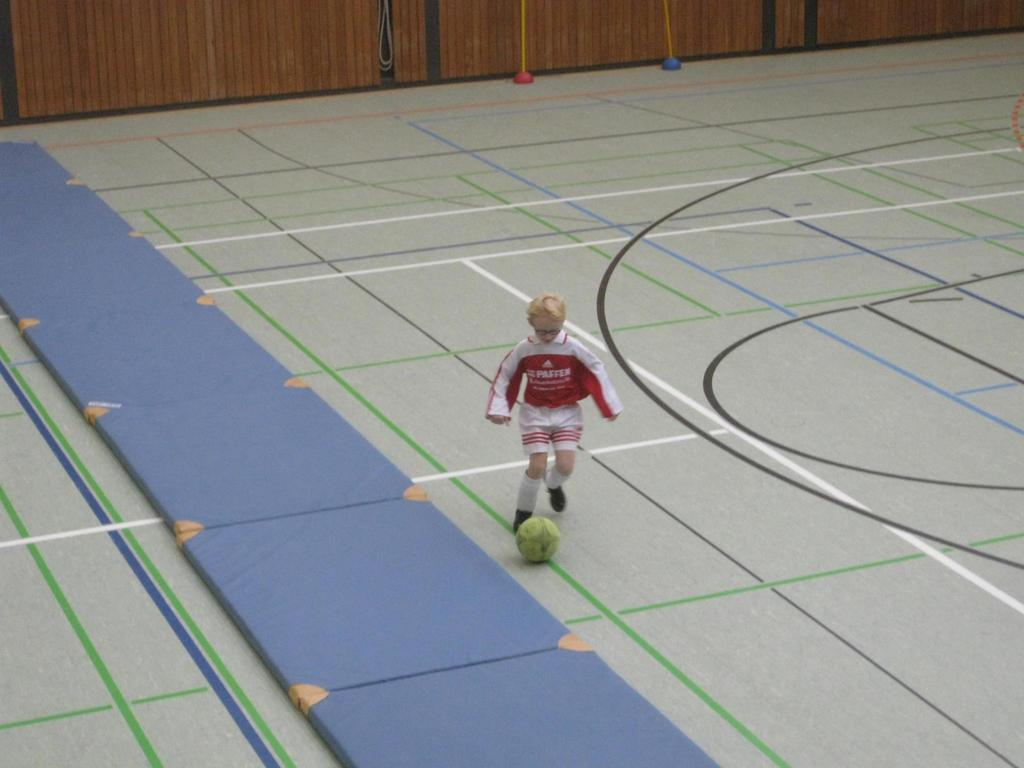Provide a one-sentence caption for the provided image. A little boy that is wearing a shirt that says Paffer and he's kicking a ball. 